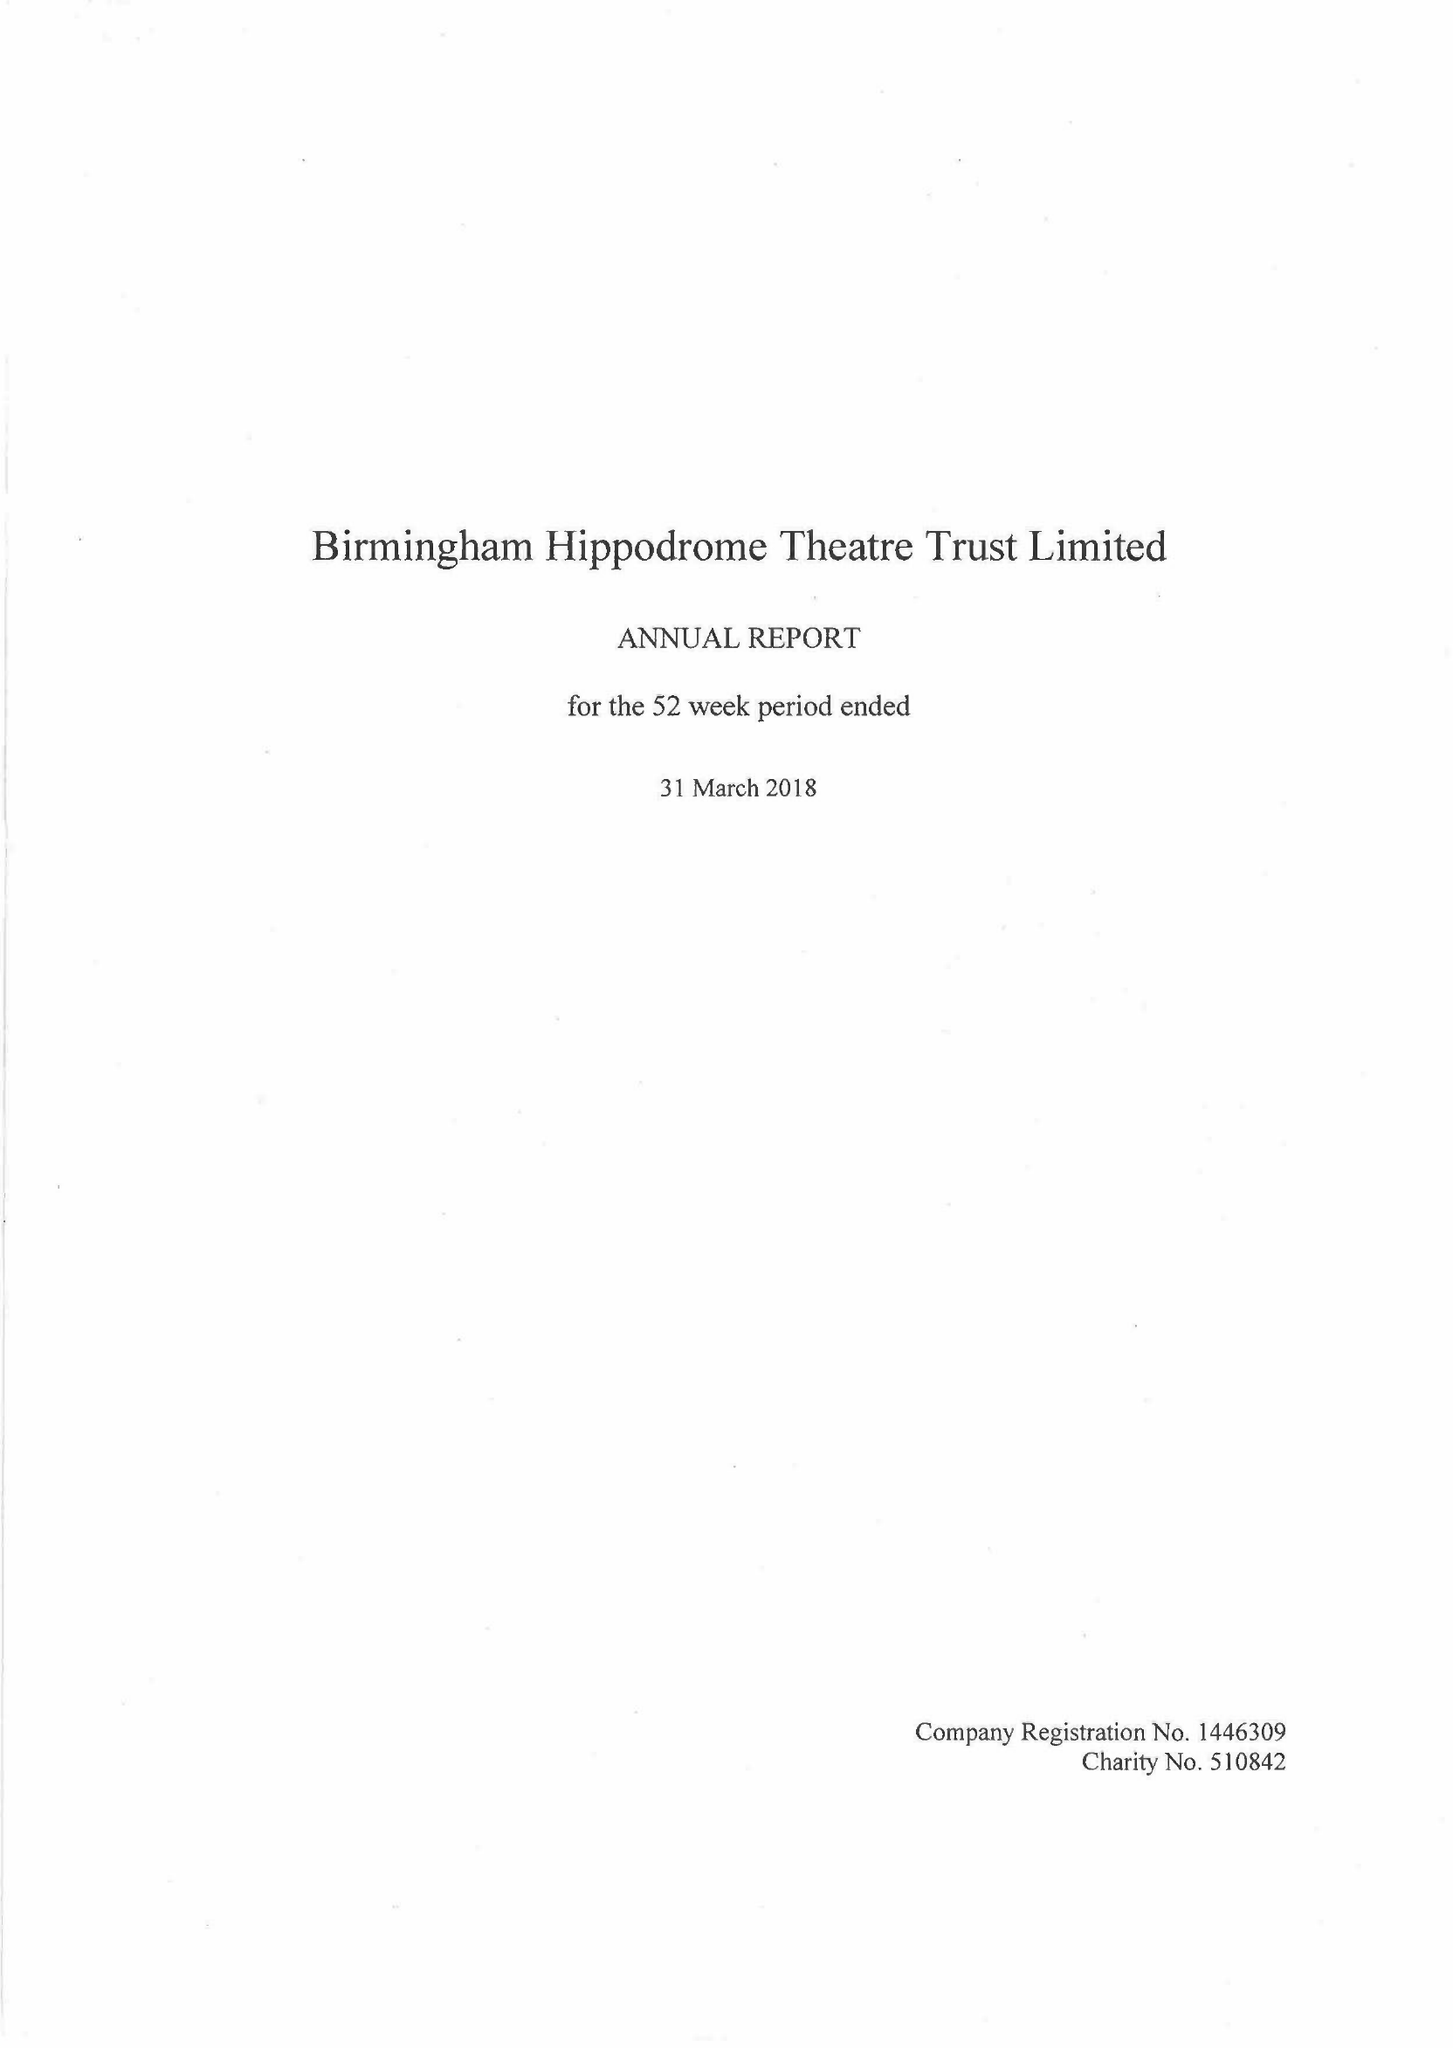What is the value for the address__post_town?
Answer the question using a single word or phrase. BIRMINGHAM 